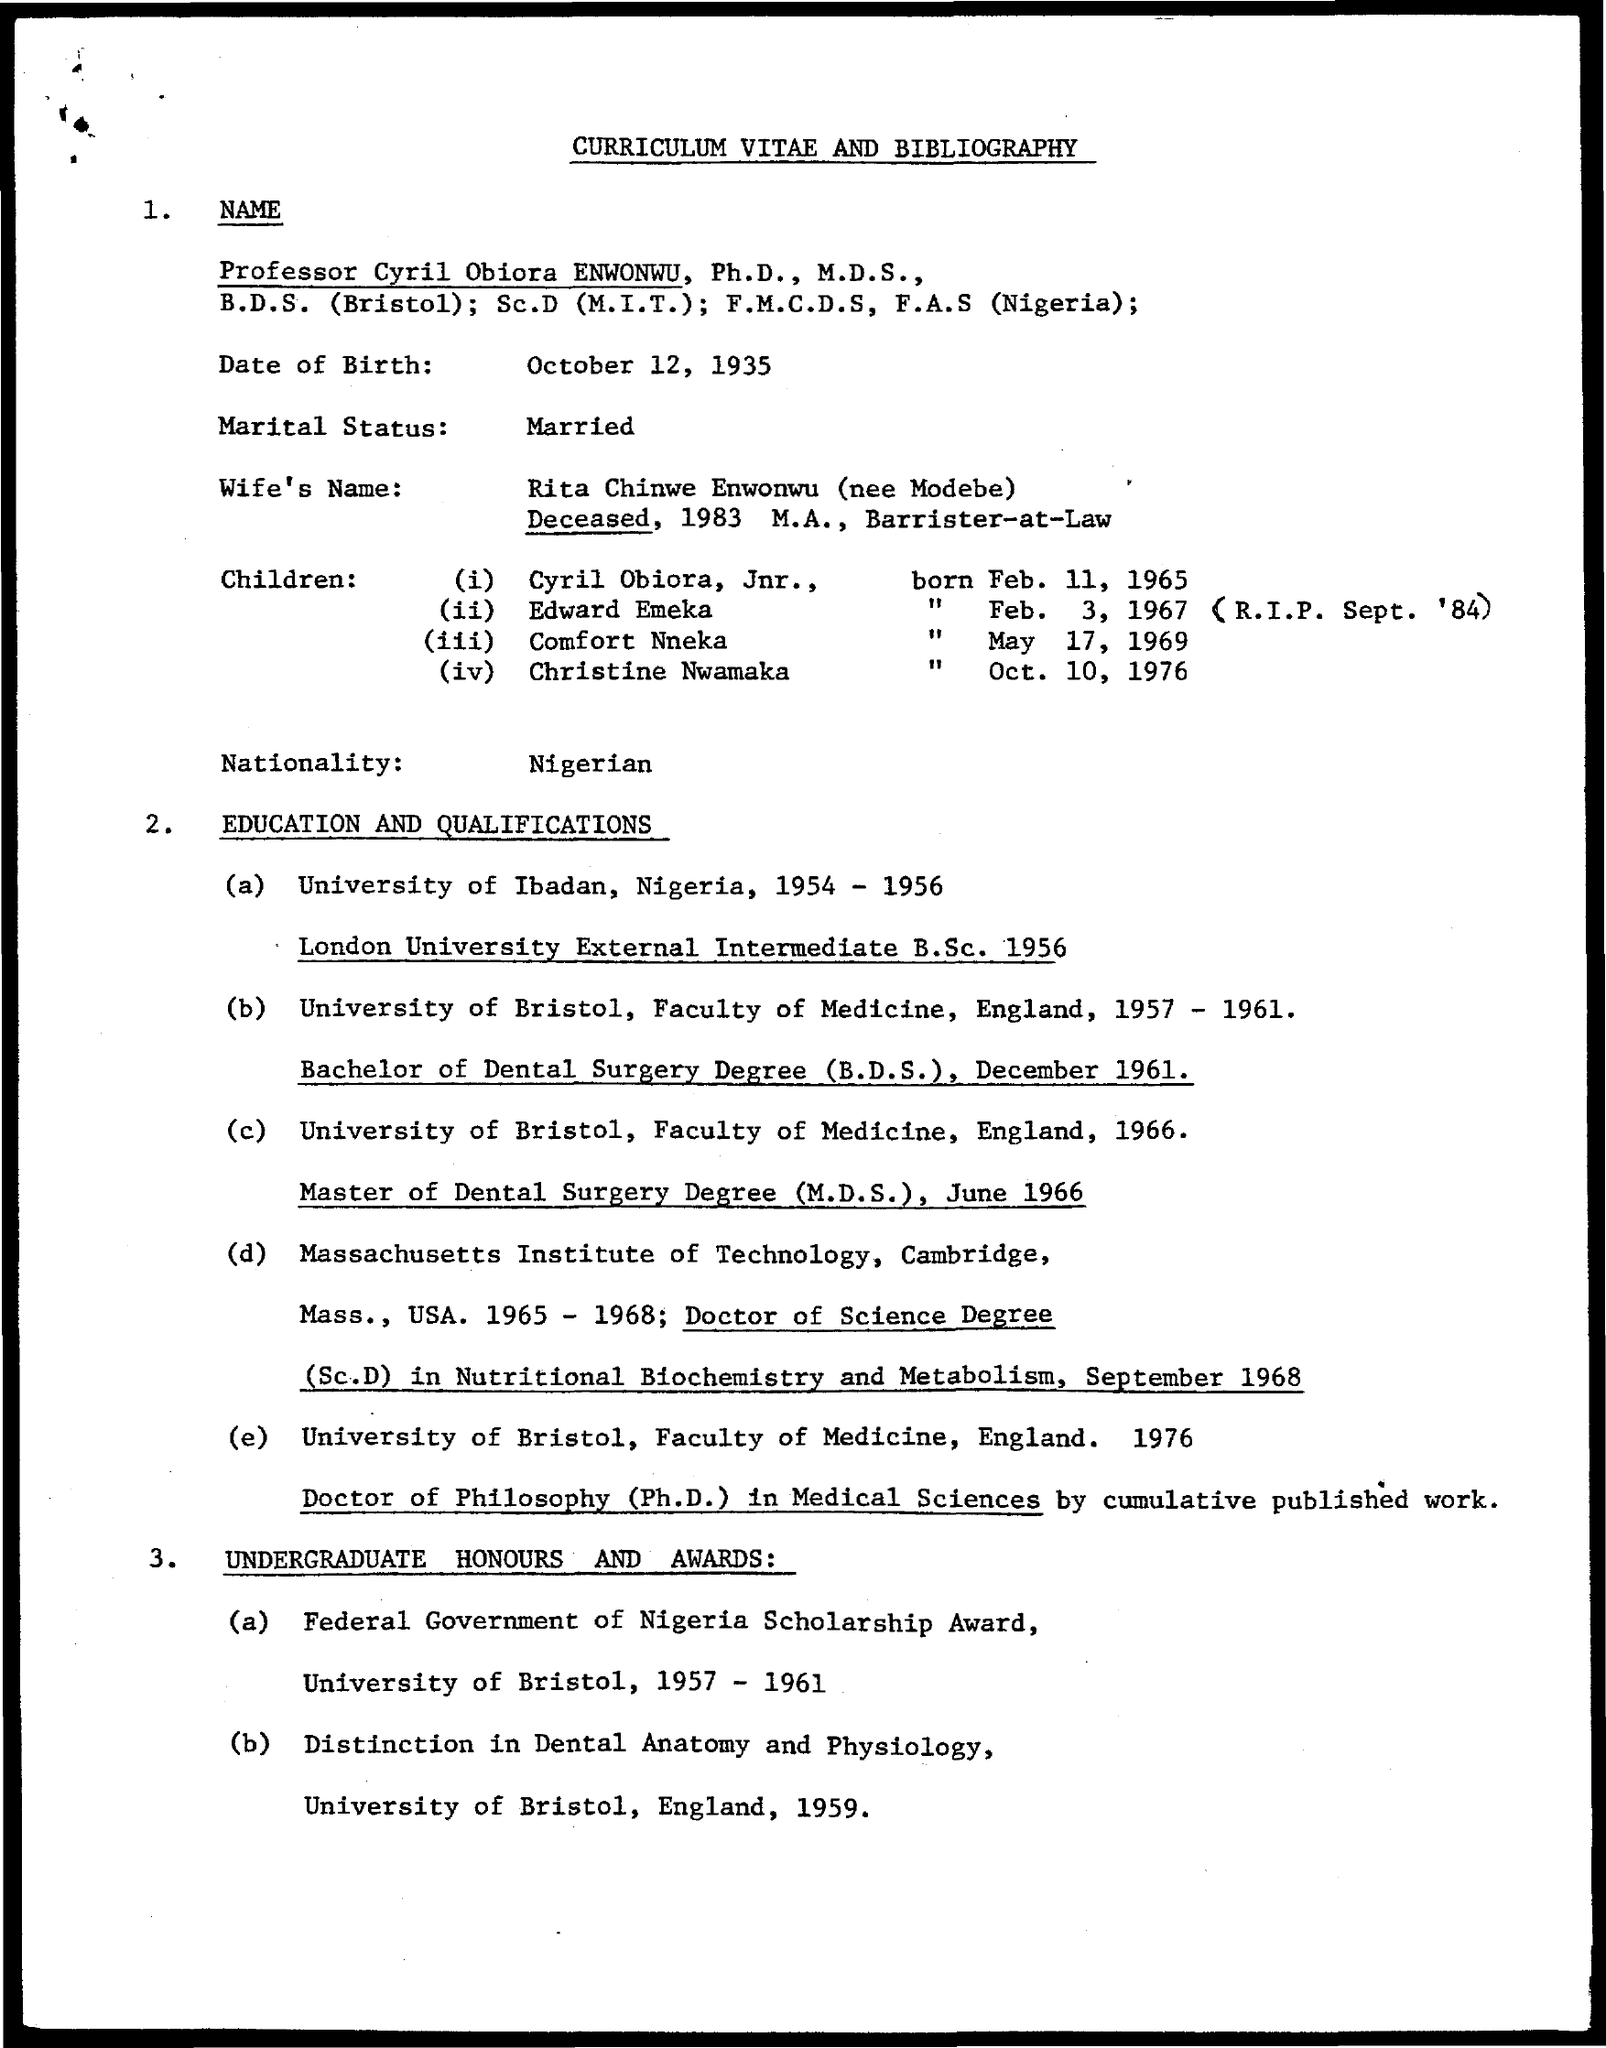Give some essential details in this illustration. Cyril Obiora ENWONWU won the Federal Government of Nigeria Scholarship Award during the years 1957 to 1961. Cyril Obiora ENWONWU was born on October 12, 1935. Cyril Obiora ENWONWU earned his Bachelor of Dental Surgery degree from the University of Bristol. Professor Cyril Obiora Enwonwu, Ph.D., M.D.S., whose curriculum vitae and bibliography are given here, is an accomplished academic and researcher in the field of medicine. Cyril Obiora ENWONWU is married. 